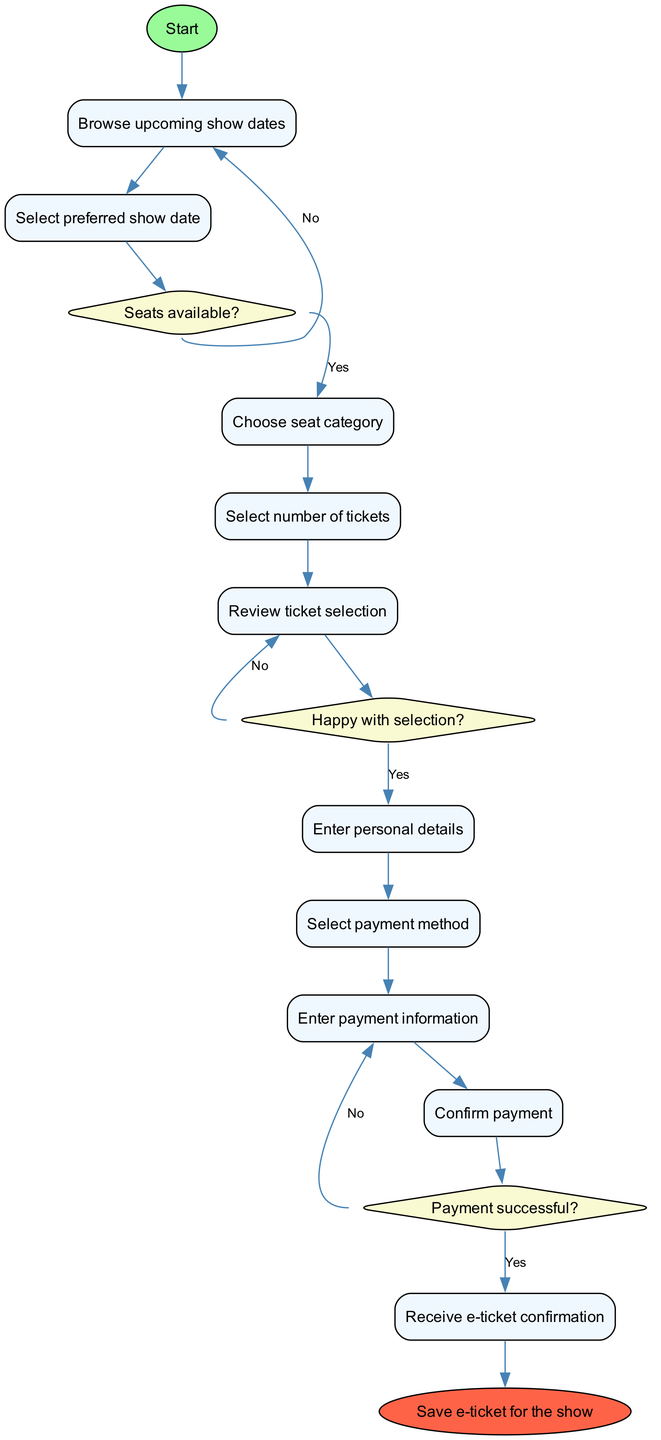What is the first activity in the booking process? The diagram starts with the node labeled "Visit Jenny Bede's official website," which represents the initial action in the booking process.
Answer: Visit Jenny Bede's official website How many activities are listed in the diagram? By counting the activities in the "activities" list, there are a total of ten distinct activities from starting at the website to saving the e-ticket.
Answer: 10 What happens if there are no seats available? According to the decision node "Seats available?" with a "No" branch, if seats are not available, the process goes back to "Browse upcoming show dates."
Answer: Browse upcoming show dates What do you do after you review your ticket selection? The process moves to the decision node "Happy with selection?" after the "Review ticket selection" node. If the answer is "Yes," the next step is to "Enter personal details."
Answer: Enter personal details What does the final activity lead to? The final activity in the process is "Save e-ticket for the show," indicating that upon completion of all prior steps, this is the last action taken.
Answer: Save e-ticket for the show If payment is not successful, what is the next step? When the "Payment successful?" decision node indicates "No," the flow goes back to the "Enter payment information" activity, prompting the user to re-enter their payment details.
Answer: Enter payment information What type of node follows the selection of the number of tickets? The selection of the number of tickets leads to the "Review ticket selection" activity, which is a rectangular activity node according to the diagram structure.
Answer: Review ticket selection Which decision in the process involves satisfaction with the selection? The decision node titled "Happy with selection?" directly addresses whether the user is satisfied with their choice before proceeding to personal details.
Answer: Happy with selection What shape is used for the end node in the diagram? The end node, labeled "Save e-ticket for the show," is shaped like an oval as indicated by the diagram's specifications for the final node.
Answer: Oval 